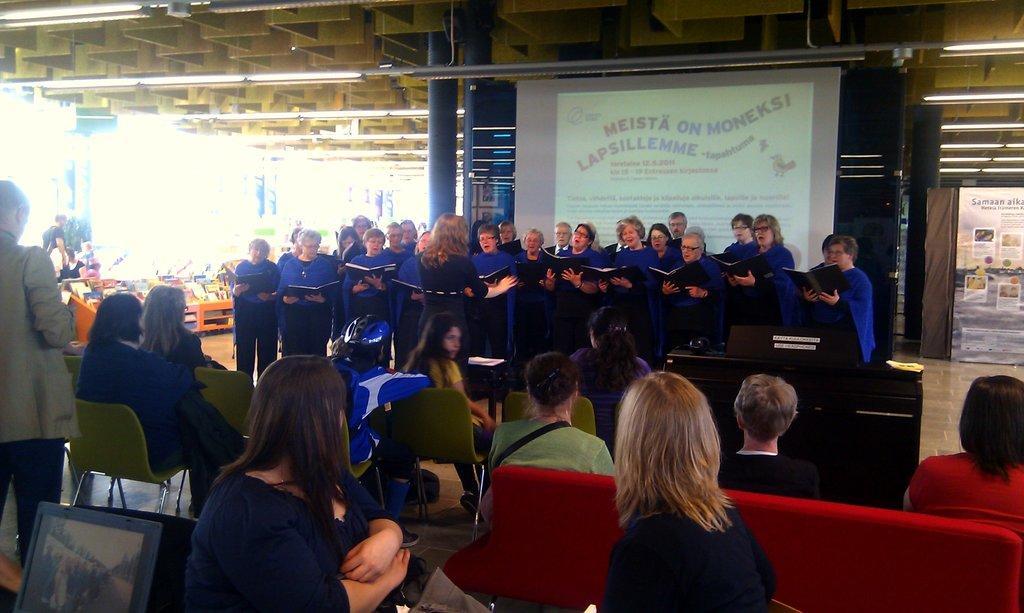In one or two sentences, can you explain what this image depicts? There are many persons in this room. Some are sitting and some are standing. Persons in the back wearing blue dress is holding book. In the background there is a banner, pillars. There are chairs laptops. 